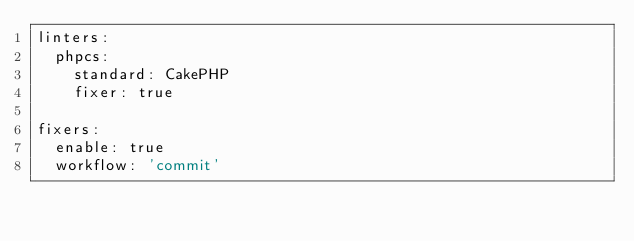<code> <loc_0><loc_0><loc_500><loc_500><_YAML_>linters:
  phpcs:
    standard: CakePHP
    fixer: true

fixers:
  enable: true
  workflow: 'commit'
</code> 